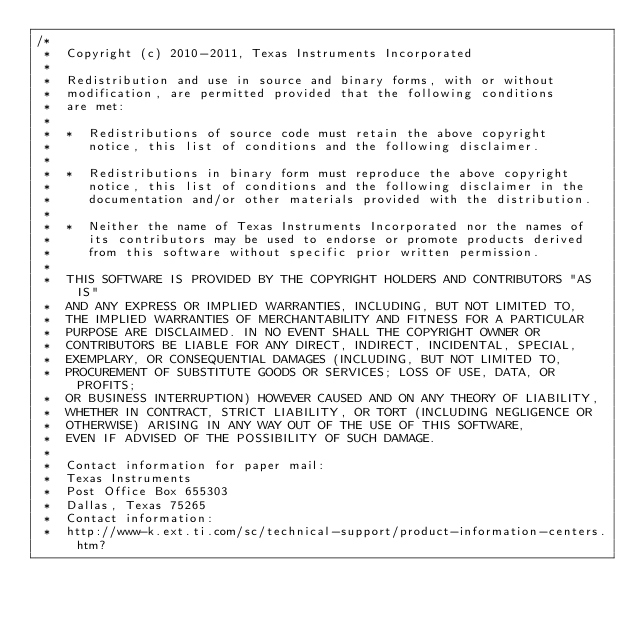Convert code to text. <code><loc_0><loc_0><loc_500><loc_500><_C_>/*
 *  Copyright (c) 2010-2011, Texas Instruments Incorporated
 *
 *  Redistribution and use in source and binary forms, with or without
 *  modification, are permitted provided that the following conditions
 *  are met:
 *
 *  *  Redistributions of source code must retain the above copyright
 *     notice, this list of conditions and the following disclaimer.
 *
 *  *  Redistributions in binary form must reproduce the above copyright
 *     notice, this list of conditions and the following disclaimer in the
 *     documentation and/or other materials provided with the distribution.
 *
 *  *  Neither the name of Texas Instruments Incorporated nor the names of
 *     its contributors may be used to endorse or promote products derived
 *     from this software without specific prior written permission.
 *
 *  THIS SOFTWARE IS PROVIDED BY THE COPYRIGHT HOLDERS AND CONTRIBUTORS "AS IS"
 *  AND ANY EXPRESS OR IMPLIED WARRANTIES, INCLUDING, BUT NOT LIMITED TO,
 *  THE IMPLIED WARRANTIES OF MERCHANTABILITY AND FITNESS FOR A PARTICULAR
 *  PURPOSE ARE DISCLAIMED. IN NO EVENT SHALL THE COPYRIGHT OWNER OR
 *  CONTRIBUTORS BE LIABLE FOR ANY DIRECT, INDIRECT, INCIDENTAL, SPECIAL,
 *  EXEMPLARY, OR CONSEQUENTIAL DAMAGES (INCLUDING, BUT NOT LIMITED TO,
 *  PROCUREMENT OF SUBSTITUTE GOODS OR SERVICES; LOSS OF USE, DATA, OR PROFITS;
 *  OR BUSINESS INTERRUPTION) HOWEVER CAUSED AND ON ANY THEORY OF LIABILITY,
 *  WHETHER IN CONTRACT, STRICT LIABILITY, OR TORT (INCLUDING NEGLIGENCE OR
 *  OTHERWISE) ARISING IN ANY WAY OUT OF THE USE OF THIS SOFTWARE,
 *  EVEN IF ADVISED OF THE POSSIBILITY OF SUCH DAMAGE.
 *
 *  Contact information for paper mail:
 *  Texas Instruments
 *  Post Office Box 655303
 *  Dallas, Texas 75265
 *  Contact information:
 *  http://www-k.ext.ti.com/sc/technical-support/product-information-centers.htm?</code> 